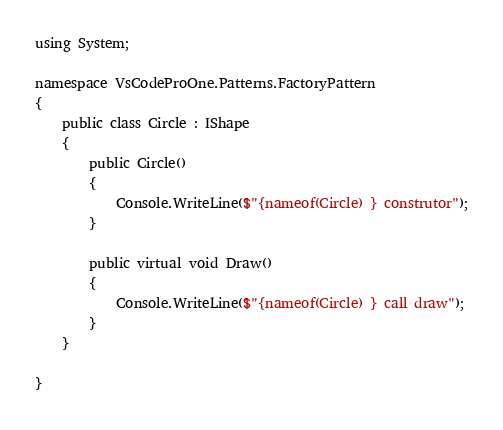<code> <loc_0><loc_0><loc_500><loc_500><_C#_>
using System;

namespace VsCodeProOne.Patterns.FactoryPattern
{
    public class Circle : IShape
    {
        public Circle()
        {
            Console.WriteLine($"{nameof(Circle) } construtor");
        }

        public virtual void Draw()
        {
            Console.WriteLine($"{nameof(Circle) } call draw");
        }
    }

}

</code> 